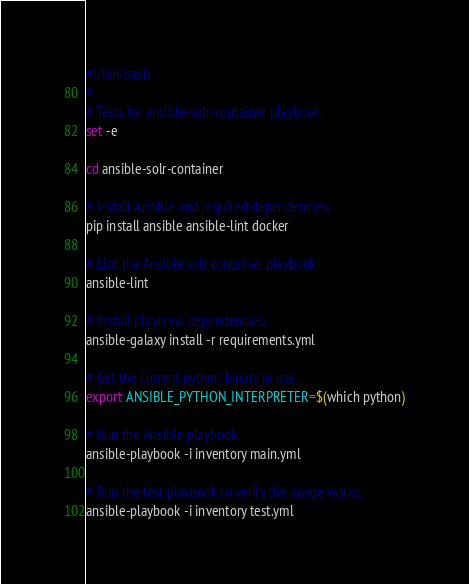<code> <loc_0><loc_0><loc_500><loc_500><_Bash_>#!/bin/bash
#
# Tests for ansible-solr-container playbook.
set -e

cd ansible-solr-container

# Install Ansible and required dependencies.
pip install ansible ansible-lint docker

# Lint the Ansible solr container playbook.
ansible-lint

# Install playbook dependencies.
ansible-galaxy install -r requirements.yml

# Get the current python binary in use.
export ANSIBLE_PYTHON_INTERPRETER=$(which python)

# Run the Ansible playbook.
ansible-playbook -i inventory main.yml

# Run the test playbook to verify the image works.
ansible-playbook -i inventory test.yml
</code> 